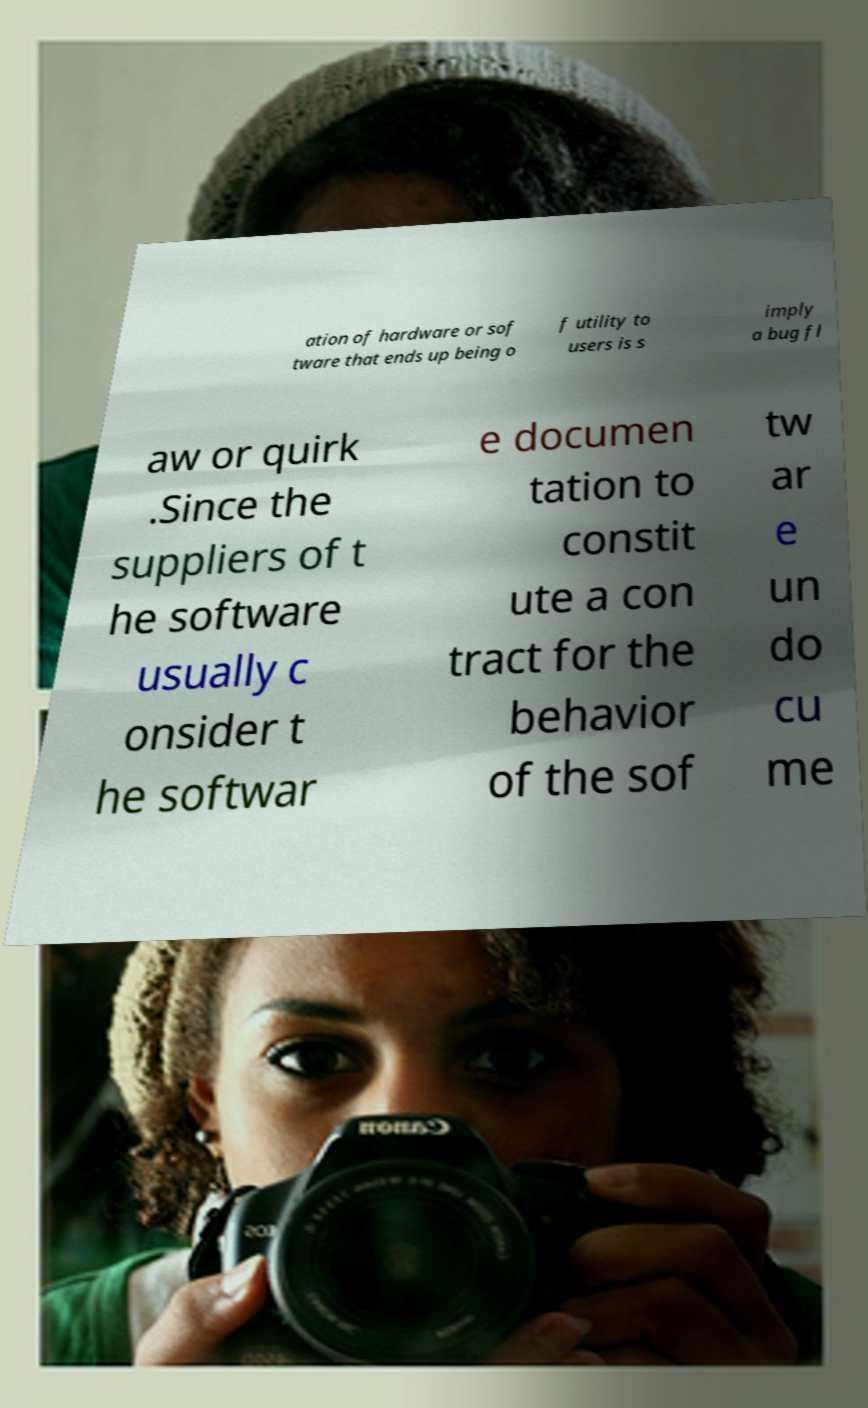For documentation purposes, I need the text within this image transcribed. Could you provide that? ation of hardware or sof tware that ends up being o f utility to users is s imply a bug fl aw or quirk .Since the suppliers of t he software usually c onsider t he softwar e documen tation to constit ute a con tract for the behavior of the sof tw ar e un do cu me 